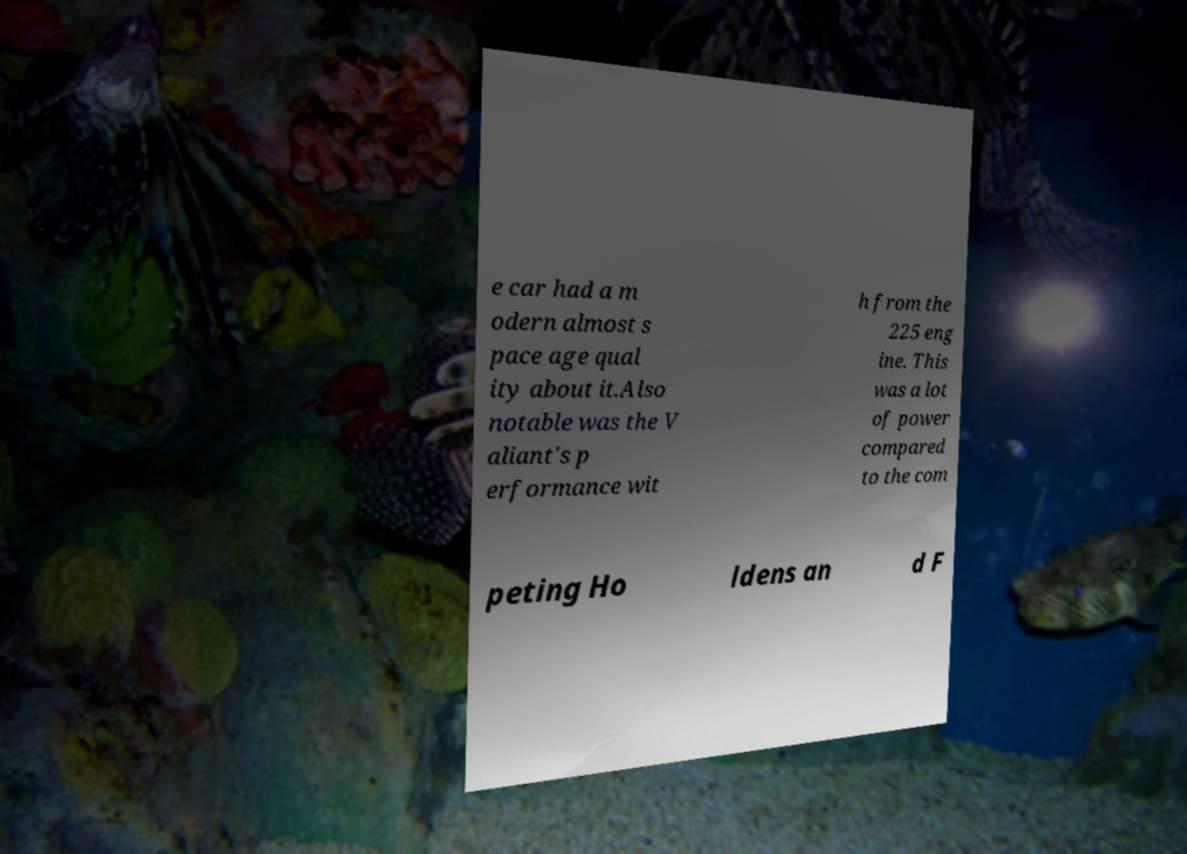Please identify and transcribe the text found in this image. e car had a m odern almost s pace age qual ity about it.Also notable was the V aliant's p erformance wit h from the 225 eng ine. This was a lot of power compared to the com peting Ho ldens an d F 